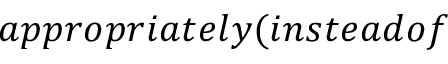<formula> <loc_0><loc_0><loc_500><loc_500>a p p r o p r i a t e l y ( i n s t e a d o f</formula> 